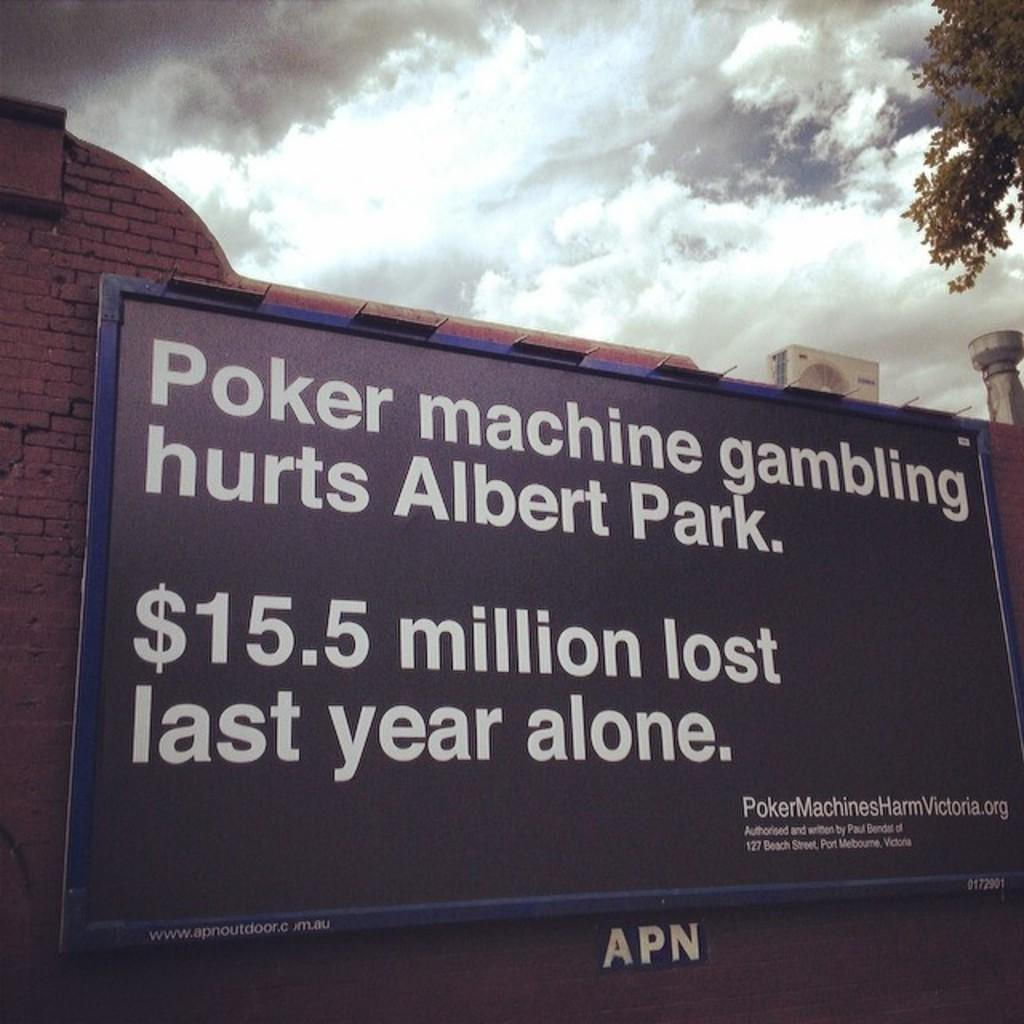<image>
Offer a succinct explanation of the picture presented. Billboard letting people know that poker machine gambling hurts Albert Park. 